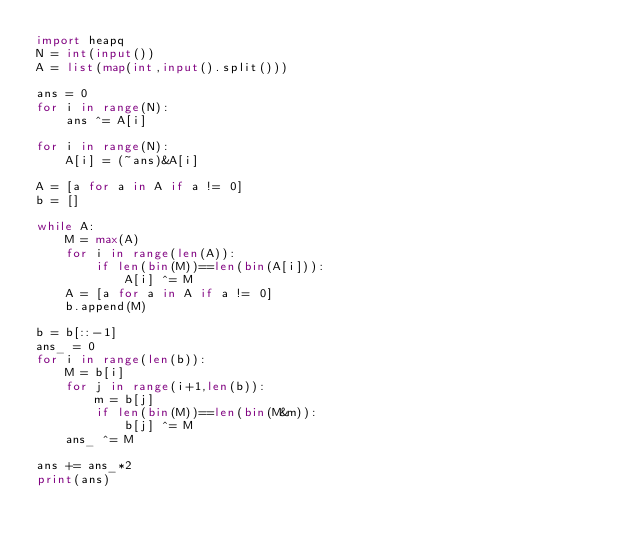Convert code to text. <code><loc_0><loc_0><loc_500><loc_500><_Python_>import heapq
N = int(input())
A = list(map(int,input().split()))

ans = 0
for i in range(N):
    ans ^= A[i]

for i in range(N):
    A[i] = (~ans)&A[i]

A = [a for a in A if a != 0]
b = []

while A:
    M = max(A)
    for i in range(len(A)):
        if len(bin(M))==len(bin(A[i])):
            A[i] ^= M
    A = [a for a in A if a != 0]
    b.append(M)    

b = b[::-1]
ans_ = 0
for i in range(len(b)):
    M = b[i]
    for j in range(i+1,len(b)):
        m = b[j]
        if len(bin(M))==len(bin(M&m)):
            b[j] ^= M
    ans_ ^= M

ans += ans_*2
print(ans)</code> 